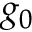Convert formula to latex. <formula><loc_0><loc_0><loc_500><loc_500>g _ { 0 }</formula> 